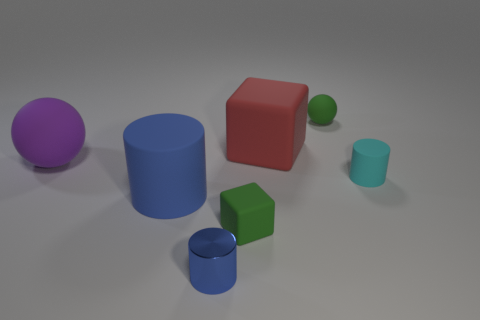Can you describe the shapes and colors of the objects in the image? Certainly! The image features a collection of geometric shapes in various colors. Starting from the left, there's a purple sphere, a blue cylinder, a red cube, a green cube, a smaller blue cylinder, and a smaller cyan cube. Each shape is placed on a flat surface, giving the scene a clean and organized appearance. 